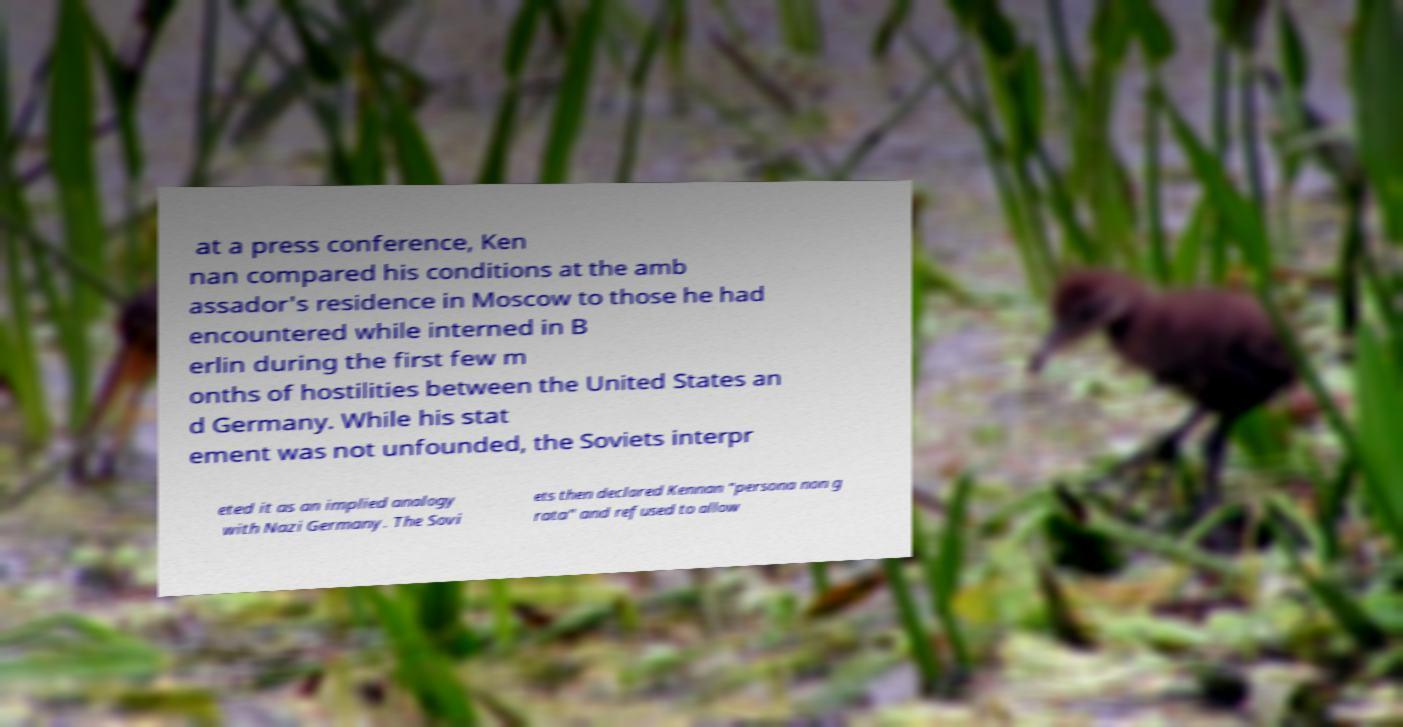Could you extract and type out the text from this image? at a press conference, Ken nan compared his conditions at the amb assador's residence in Moscow to those he had encountered while interned in B erlin during the first few m onths of hostilities between the United States an d Germany. While his stat ement was not unfounded, the Soviets interpr eted it as an implied analogy with Nazi Germany. The Sovi ets then declared Kennan "persona non g rata" and refused to allow 